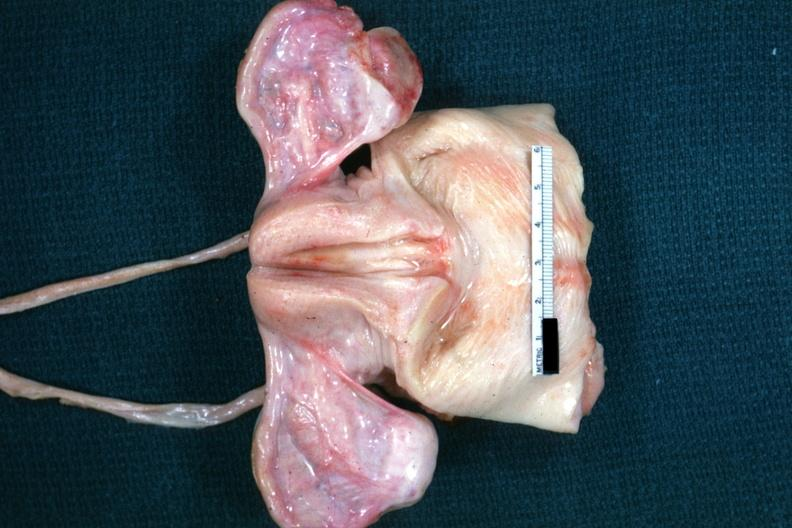what are not truly normal ovaries of vacant sella but externally i can see nothing?
Answer the question using a single word or phrase. Non functional in this case 